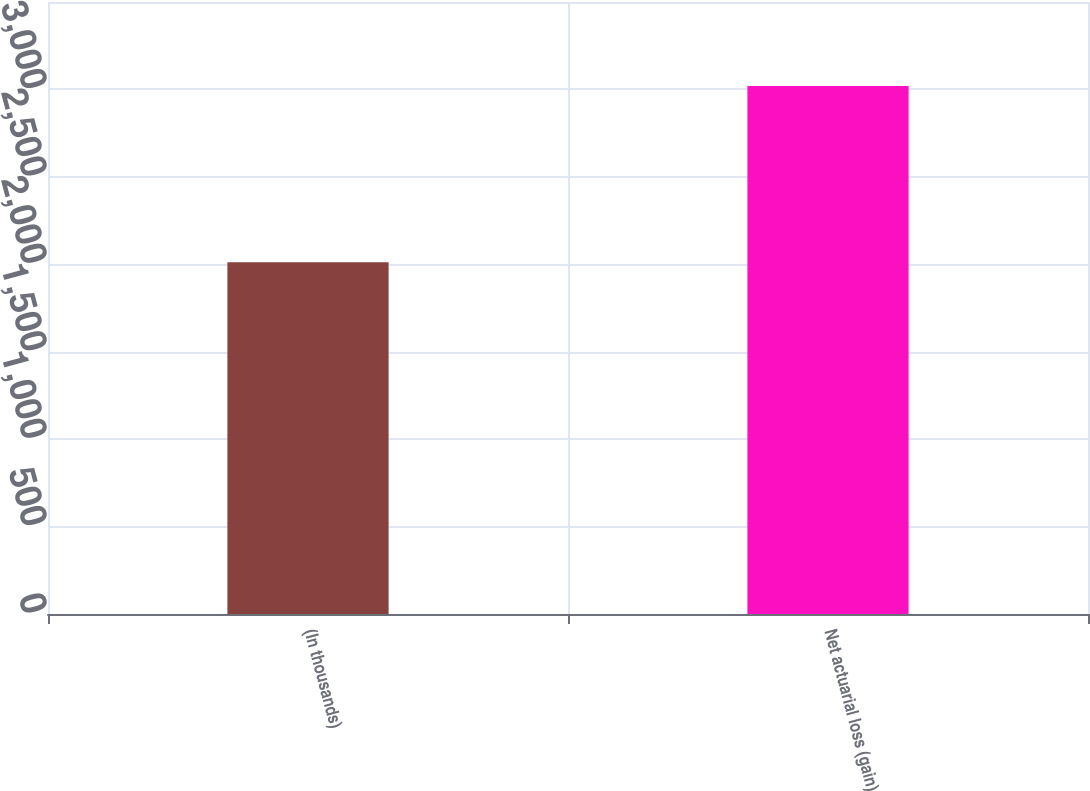Convert chart. <chart><loc_0><loc_0><loc_500><loc_500><bar_chart><fcel>(In thousands)<fcel>Net actuarial loss (gain)<nl><fcel>2011<fcel>3020<nl></chart> 